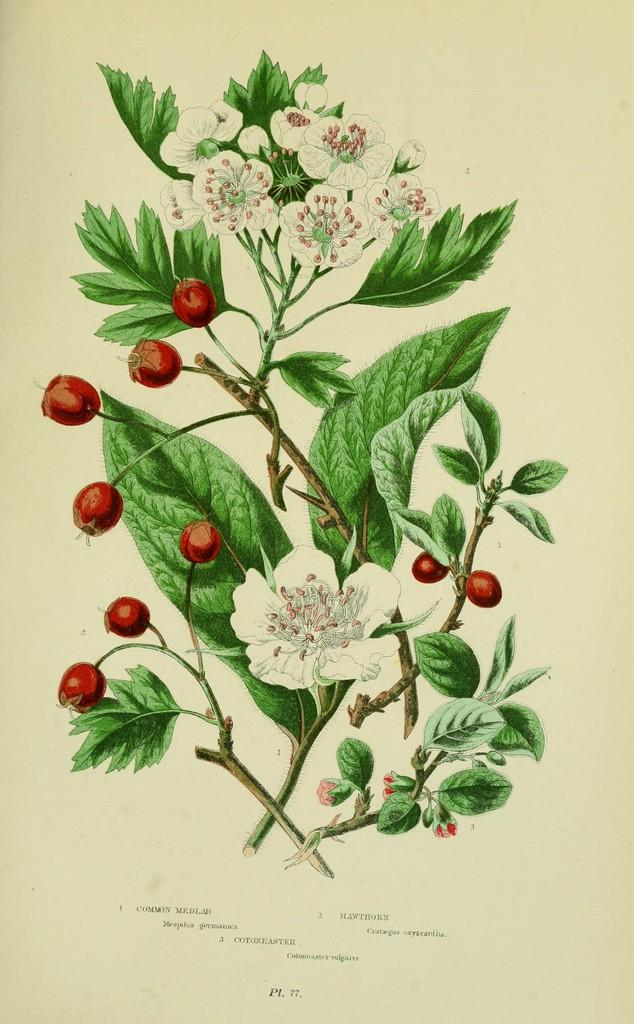What is depicted in the image in the picture? There is a picture of a paper in the image. What can be seen on the paper? The paper contains an image of stems with flowers and fruits. Is there any text on the paper? Yes, there is some text at the bottom of the paper. Can you see a knife cutting the fruits in the image? There is no knife or any cutting action depicted in the image. The image only shows a paper with an illustration of stems, flowers, and fruits, along with some text at the bottom. 